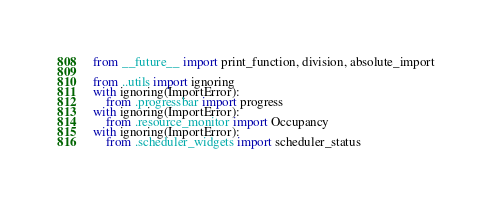<code> <loc_0><loc_0><loc_500><loc_500><_Python_>from __future__ import print_function, division, absolute_import

from ..utils import ignoring
with ignoring(ImportError):
    from .progressbar import progress
with ignoring(ImportError):
    from .resource_monitor import Occupancy
with ignoring(ImportError):
    from .scheduler_widgets import scheduler_status
</code> 